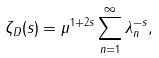<formula> <loc_0><loc_0><loc_500><loc_500>\zeta _ { D } ( s ) = \mu ^ { 1 + 2 s } \sum _ { n = 1 } ^ { \infty } \lambda _ { n } ^ { - s } ,</formula> 